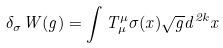Convert formula to latex. <formula><loc_0><loc_0><loc_500><loc_500>\delta _ { \sigma } W ( g ) = \int T ^ { \mu } _ { \mu } \sigma ( x ) \sqrt { g } d ^ { 2 k } x</formula> 